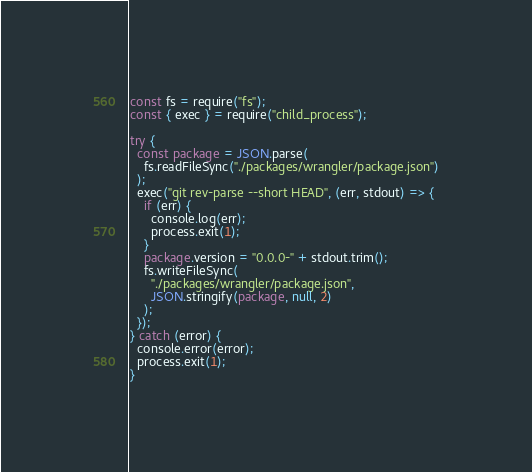<code> <loc_0><loc_0><loc_500><loc_500><_JavaScript_>const fs = require("fs");
const { exec } = require("child_process");

try {
  const package = JSON.parse(
    fs.readFileSync("./packages/wrangler/package.json")
  );
  exec("git rev-parse --short HEAD", (err, stdout) => {
    if (err) {
      console.log(err);
      process.exit(1);
    }
    package.version = "0.0.0-" + stdout.trim();
    fs.writeFileSync(
      "./packages/wrangler/package.json",
      JSON.stringify(package, null, 2)
    );
  });
} catch (error) {
  console.error(error);
  process.exit(1);
}
</code> 